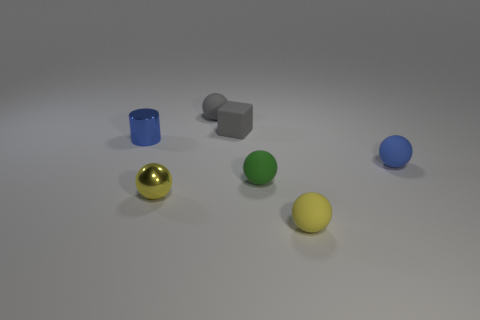How many other things are the same size as the green matte object?
Your answer should be compact. 6. Are there more small yellow metallic objects that are left of the green object than small blue objects?
Offer a very short reply. No. How many things are gray objects or small rubber things that are to the right of the gray sphere?
Offer a very short reply. 5. Is the number of small gray cubes that are on the left side of the green rubber ball greater than the number of tiny yellow metal balls that are behind the blue ball?
Give a very brief answer. Yes. There is a yellow object that is behind the yellow thing that is right of the small gray matte sphere behind the tiny yellow shiny object; what is it made of?
Offer a very short reply. Metal. What is the shape of the tiny yellow thing that is the same material as the tiny cylinder?
Offer a terse response. Sphere. There is a matte thing on the right side of the tiny yellow rubber object; are there any small rubber balls that are in front of it?
Your answer should be very brief. Yes. How big is the green sphere?
Your response must be concise. Small. How many objects are gray matte things or cubes?
Ensure brevity in your answer.  2. Is the material of the blue thing to the left of the small blue sphere the same as the tiny yellow ball right of the tiny green ball?
Your response must be concise. No. 